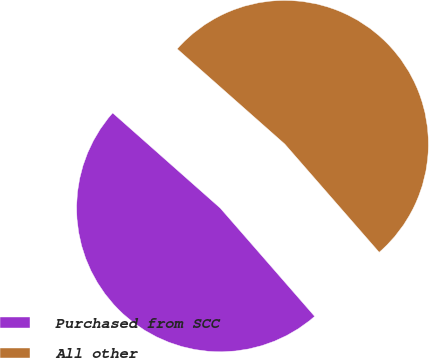<chart> <loc_0><loc_0><loc_500><loc_500><pie_chart><fcel>Purchased from SCC<fcel>All other<nl><fcel>47.94%<fcel>52.06%<nl></chart> 